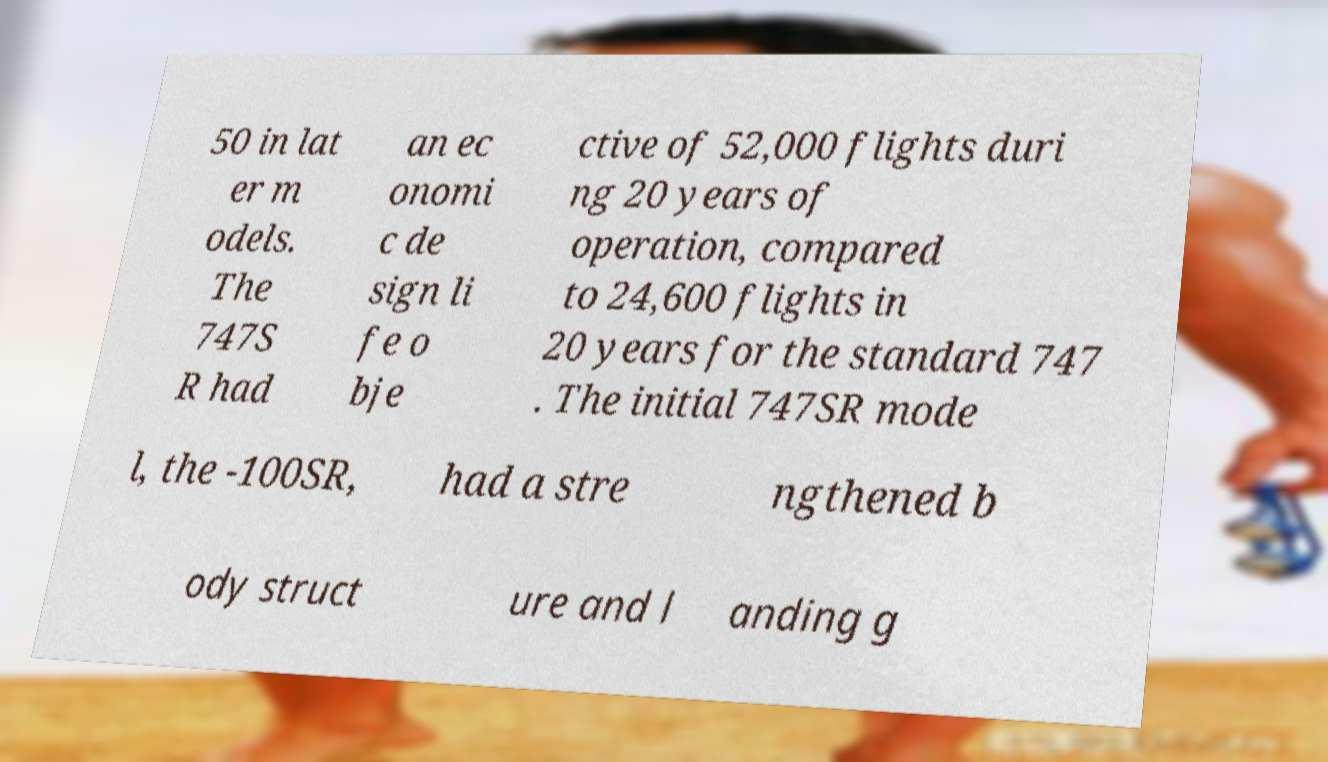For documentation purposes, I need the text within this image transcribed. Could you provide that? 50 in lat er m odels. The 747S R had an ec onomi c de sign li fe o bje ctive of 52,000 flights duri ng 20 years of operation, compared to 24,600 flights in 20 years for the standard 747 . The initial 747SR mode l, the -100SR, had a stre ngthened b ody struct ure and l anding g 